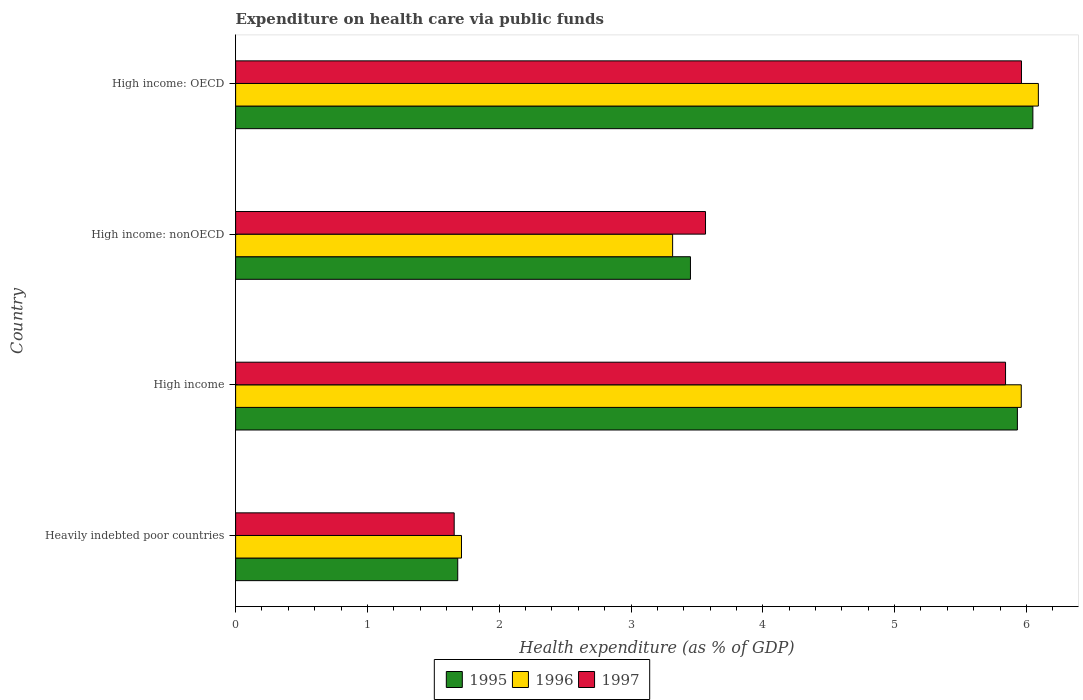Are the number of bars per tick equal to the number of legend labels?
Your answer should be compact. Yes. Are the number of bars on each tick of the Y-axis equal?
Your answer should be compact. Yes. How many bars are there on the 1st tick from the top?
Your answer should be very brief. 3. What is the label of the 2nd group of bars from the top?
Your response must be concise. High income: nonOECD. In how many cases, is the number of bars for a given country not equal to the number of legend labels?
Keep it short and to the point. 0. What is the expenditure made on health care in 1995 in High income?
Give a very brief answer. 5.93. Across all countries, what is the maximum expenditure made on health care in 1996?
Give a very brief answer. 6.09. Across all countries, what is the minimum expenditure made on health care in 1996?
Keep it short and to the point. 1.71. In which country was the expenditure made on health care in 1996 maximum?
Give a very brief answer. High income: OECD. In which country was the expenditure made on health care in 1996 minimum?
Your response must be concise. Heavily indebted poor countries. What is the total expenditure made on health care in 1995 in the graph?
Give a very brief answer. 17.12. What is the difference between the expenditure made on health care in 1997 in High income: OECD and that in High income: nonOECD?
Provide a short and direct response. 2.4. What is the difference between the expenditure made on health care in 1996 in Heavily indebted poor countries and the expenditure made on health care in 1995 in High income: nonOECD?
Your answer should be very brief. -1.74. What is the average expenditure made on health care in 1997 per country?
Provide a succinct answer. 4.26. What is the difference between the expenditure made on health care in 1995 and expenditure made on health care in 1997 in High income?
Offer a very short reply. 0.09. What is the ratio of the expenditure made on health care in 1997 in High income to that in High income: OECD?
Make the answer very short. 0.98. Is the expenditure made on health care in 1996 in High income less than that in High income: nonOECD?
Ensure brevity in your answer.  No. Is the difference between the expenditure made on health care in 1995 in High income: OECD and High income: nonOECD greater than the difference between the expenditure made on health care in 1997 in High income: OECD and High income: nonOECD?
Offer a terse response. Yes. What is the difference between the highest and the second highest expenditure made on health care in 1997?
Your response must be concise. 0.12. What is the difference between the highest and the lowest expenditure made on health care in 1995?
Provide a short and direct response. 4.36. In how many countries, is the expenditure made on health care in 1997 greater than the average expenditure made on health care in 1997 taken over all countries?
Provide a succinct answer. 2. Is the sum of the expenditure made on health care in 1997 in Heavily indebted poor countries and High income: nonOECD greater than the maximum expenditure made on health care in 1995 across all countries?
Your answer should be very brief. No. What does the 1st bar from the bottom in High income: nonOECD represents?
Offer a very short reply. 1995. Is it the case that in every country, the sum of the expenditure made on health care in 1997 and expenditure made on health care in 1995 is greater than the expenditure made on health care in 1996?
Your answer should be very brief. Yes. What is the difference between two consecutive major ticks on the X-axis?
Make the answer very short. 1. Does the graph contain grids?
Provide a succinct answer. No. Where does the legend appear in the graph?
Your response must be concise. Bottom center. What is the title of the graph?
Keep it short and to the point. Expenditure on health care via public funds. Does "1997" appear as one of the legend labels in the graph?
Keep it short and to the point. Yes. What is the label or title of the X-axis?
Make the answer very short. Health expenditure (as % of GDP). What is the label or title of the Y-axis?
Provide a succinct answer. Country. What is the Health expenditure (as % of GDP) in 1995 in Heavily indebted poor countries?
Keep it short and to the point. 1.69. What is the Health expenditure (as % of GDP) in 1996 in Heavily indebted poor countries?
Offer a terse response. 1.71. What is the Health expenditure (as % of GDP) in 1997 in Heavily indebted poor countries?
Provide a succinct answer. 1.66. What is the Health expenditure (as % of GDP) in 1995 in High income?
Your answer should be very brief. 5.93. What is the Health expenditure (as % of GDP) in 1996 in High income?
Keep it short and to the point. 5.96. What is the Health expenditure (as % of GDP) of 1997 in High income?
Offer a terse response. 5.84. What is the Health expenditure (as % of GDP) of 1995 in High income: nonOECD?
Offer a terse response. 3.45. What is the Health expenditure (as % of GDP) in 1996 in High income: nonOECD?
Make the answer very short. 3.32. What is the Health expenditure (as % of GDP) of 1997 in High income: nonOECD?
Your answer should be very brief. 3.57. What is the Health expenditure (as % of GDP) of 1995 in High income: OECD?
Offer a very short reply. 6.05. What is the Health expenditure (as % of GDP) of 1996 in High income: OECD?
Offer a very short reply. 6.09. What is the Health expenditure (as % of GDP) in 1997 in High income: OECD?
Your response must be concise. 5.96. Across all countries, what is the maximum Health expenditure (as % of GDP) of 1995?
Make the answer very short. 6.05. Across all countries, what is the maximum Health expenditure (as % of GDP) in 1996?
Make the answer very short. 6.09. Across all countries, what is the maximum Health expenditure (as % of GDP) in 1997?
Your response must be concise. 5.96. Across all countries, what is the minimum Health expenditure (as % of GDP) of 1995?
Your answer should be compact. 1.69. Across all countries, what is the minimum Health expenditure (as % of GDP) in 1996?
Provide a succinct answer. 1.71. Across all countries, what is the minimum Health expenditure (as % of GDP) of 1997?
Provide a succinct answer. 1.66. What is the total Health expenditure (as % of GDP) in 1995 in the graph?
Provide a short and direct response. 17.12. What is the total Health expenditure (as % of GDP) of 1996 in the graph?
Your answer should be compact. 17.08. What is the total Health expenditure (as % of GDP) of 1997 in the graph?
Ensure brevity in your answer.  17.03. What is the difference between the Health expenditure (as % of GDP) of 1995 in Heavily indebted poor countries and that in High income?
Provide a succinct answer. -4.25. What is the difference between the Health expenditure (as % of GDP) in 1996 in Heavily indebted poor countries and that in High income?
Provide a succinct answer. -4.25. What is the difference between the Health expenditure (as % of GDP) in 1997 in Heavily indebted poor countries and that in High income?
Provide a succinct answer. -4.18. What is the difference between the Health expenditure (as % of GDP) in 1995 in Heavily indebted poor countries and that in High income: nonOECD?
Offer a terse response. -1.77. What is the difference between the Health expenditure (as % of GDP) in 1996 in Heavily indebted poor countries and that in High income: nonOECD?
Your answer should be very brief. -1.6. What is the difference between the Health expenditure (as % of GDP) of 1997 in Heavily indebted poor countries and that in High income: nonOECD?
Give a very brief answer. -1.91. What is the difference between the Health expenditure (as % of GDP) in 1995 in Heavily indebted poor countries and that in High income: OECD?
Your answer should be compact. -4.36. What is the difference between the Health expenditure (as % of GDP) of 1996 in Heavily indebted poor countries and that in High income: OECD?
Your answer should be compact. -4.38. What is the difference between the Health expenditure (as % of GDP) of 1997 in Heavily indebted poor countries and that in High income: OECD?
Your answer should be compact. -4.3. What is the difference between the Health expenditure (as % of GDP) of 1995 in High income and that in High income: nonOECD?
Your answer should be compact. 2.48. What is the difference between the Health expenditure (as % of GDP) of 1996 in High income and that in High income: nonOECD?
Provide a short and direct response. 2.65. What is the difference between the Health expenditure (as % of GDP) of 1997 in High income and that in High income: nonOECD?
Keep it short and to the point. 2.28. What is the difference between the Health expenditure (as % of GDP) of 1995 in High income and that in High income: OECD?
Make the answer very short. -0.12. What is the difference between the Health expenditure (as % of GDP) of 1996 in High income and that in High income: OECD?
Provide a short and direct response. -0.13. What is the difference between the Health expenditure (as % of GDP) of 1997 in High income and that in High income: OECD?
Provide a short and direct response. -0.12. What is the difference between the Health expenditure (as % of GDP) in 1995 in High income: nonOECD and that in High income: OECD?
Offer a terse response. -2.6. What is the difference between the Health expenditure (as % of GDP) of 1996 in High income: nonOECD and that in High income: OECD?
Your answer should be compact. -2.77. What is the difference between the Health expenditure (as % of GDP) of 1997 in High income: nonOECD and that in High income: OECD?
Offer a terse response. -2.4. What is the difference between the Health expenditure (as % of GDP) of 1995 in Heavily indebted poor countries and the Health expenditure (as % of GDP) of 1996 in High income?
Give a very brief answer. -4.28. What is the difference between the Health expenditure (as % of GDP) of 1995 in Heavily indebted poor countries and the Health expenditure (as % of GDP) of 1997 in High income?
Make the answer very short. -4.16. What is the difference between the Health expenditure (as % of GDP) in 1996 in Heavily indebted poor countries and the Health expenditure (as % of GDP) in 1997 in High income?
Offer a terse response. -4.13. What is the difference between the Health expenditure (as % of GDP) in 1995 in Heavily indebted poor countries and the Health expenditure (as % of GDP) in 1996 in High income: nonOECD?
Your response must be concise. -1.63. What is the difference between the Health expenditure (as % of GDP) in 1995 in Heavily indebted poor countries and the Health expenditure (as % of GDP) in 1997 in High income: nonOECD?
Keep it short and to the point. -1.88. What is the difference between the Health expenditure (as % of GDP) in 1996 in Heavily indebted poor countries and the Health expenditure (as % of GDP) in 1997 in High income: nonOECD?
Ensure brevity in your answer.  -1.85. What is the difference between the Health expenditure (as % of GDP) in 1995 in Heavily indebted poor countries and the Health expenditure (as % of GDP) in 1996 in High income: OECD?
Offer a very short reply. -4.41. What is the difference between the Health expenditure (as % of GDP) of 1995 in Heavily indebted poor countries and the Health expenditure (as % of GDP) of 1997 in High income: OECD?
Offer a terse response. -4.28. What is the difference between the Health expenditure (as % of GDP) in 1996 in Heavily indebted poor countries and the Health expenditure (as % of GDP) in 1997 in High income: OECD?
Your answer should be very brief. -4.25. What is the difference between the Health expenditure (as % of GDP) in 1995 in High income and the Health expenditure (as % of GDP) in 1996 in High income: nonOECD?
Your answer should be very brief. 2.62. What is the difference between the Health expenditure (as % of GDP) of 1995 in High income and the Health expenditure (as % of GDP) of 1997 in High income: nonOECD?
Ensure brevity in your answer.  2.37. What is the difference between the Health expenditure (as % of GDP) in 1996 in High income and the Health expenditure (as % of GDP) in 1997 in High income: nonOECD?
Offer a terse response. 2.4. What is the difference between the Health expenditure (as % of GDP) of 1995 in High income and the Health expenditure (as % of GDP) of 1996 in High income: OECD?
Your answer should be compact. -0.16. What is the difference between the Health expenditure (as % of GDP) in 1995 in High income and the Health expenditure (as % of GDP) in 1997 in High income: OECD?
Offer a terse response. -0.03. What is the difference between the Health expenditure (as % of GDP) in 1996 in High income and the Health expenditure (as % of GDP) in 1997 in High income: OECD?
Give a very brief answer. -0. What is the difference between the Health expenditure (as % of GDP) in 1995 in High income: nonOECD and the Health expenditure (as % of GDP) in 1996 in High income: OECD?
Give a very brief answer. -2.64. What is the difference between the Health expenditure (as % of GDP) in 1995 in High income: nonOECD and the Health expenditure (as % of GDP) in 1997 in High income: OECD?
Your answer should be very brief. -2.51. What is the difference between the Health expenditure (as % of GDP) in 1996 in High income: nonOECD and the Health expenditure (as % of GDP) in 1997 in High income: OECD?
Offer a very short reply. -2.65. What is the average Health expenditure (as % of GDP) of 1995 per country?
Your response must be concise. 4.28. What is the average Health expenditure (as % of GDP) in 1996 per country?
Offer a very short reply. 4.27. What is the average Health expenditure (as % of GDP) of 1997 per country?
Your response must be concise. 4.26. What is the difference between the Health expenditure (as % of GDP) in 1995 and Health expenditure (as % of GDP) in 1996 in Heavily indebted poor countries?
Your answer should be compact. -0.03. What is the difference between the Health expenditure (as % of GDP) in 1995 and Health expenditure (as % of GDP) in 1997 in Heavily indebted poor countries?
Ensure brevity in your answer.  0.03. What is the difference between the Health expenditure (as % of GDP) of 1996 and Health expenditure (as % of GDP) of 1997 in Heavily indebted poor countries?
Your answer should be compact. 0.06. What is the difference between the Health expenditure (as % of GDP) in 1995 and Health expenditure (as % of GDP) in 1996 in High income?
Give a very brief answer. -0.03. What is the difference between the Health expenditure (as % of GDP) of 1995 and Health expenditure (as % of GDP) of 1997 in High income?
Offer a terse response. 0.09. What is the difference between the Health expenditure (as % of GDP) of 1996 and Health expenditure (as % of GDP) of 1997 in High income?
Offer a terse response. 0.12. What is the difference between the Health expenditure (as % of GDP) in 1995 and Health expenditure (as % of GDP) in 1996 in High income: nonOECD?
Provide a short and direct response. 0.14. What is the difference between the Health expenditure (as % of GDP) in 1995 and Health expenditure (as % of GDP) in 1997 in High income: nonOECD?
Ensure brevity in your answer.  -0.11. What is the difference between the Health expenditure (as % of GDP) of 1996 and Health expenditure (as % of GDP) of 1997 in High income: nonOECD?
Keep it short and to the point. -0.25. What is the difference between the Health expenditure (as % of GDP) of 1995 and Health expenditure (as % of GDP) of 1996 in High income: OECD?
Offer a terse response. -0.04. What is the difference between the Health expenditure (as % of GDP) in 1995 and Health expenditure (as % of GDP) in 1997 in High income: OECD?
Offer a very short reply. 0.09. What is the difference between the Health expenditure (as % of GDP) in 1996 and Health expenditure (as % of GDP) in 1997 in High income: OECD?
Your response must be concise. 0.13. What is the ratio of the Health expenditure (as % of GDP) of 1995 in Heavily indebted poor countries to that in High income?
Provide a short and direct response. 0.28. What is the ratio of the Health expenditure (as % of GDP) in 1996 in Heavily indebted poor countries to that in High income?
Provide a short and direct response. 0.29. What is the ratio of the Health expenditure (as % of GDP) of 1997 in Heavily indebted poor countries to that in High income?
Provide a succinct answer. 0.28. What is the ratio of the Health expenditure (as % of GDP) of 1995 in Heavily indebted poor countries to that in High income: nonOECD?
Offer a terse response. 0.49. What is the ratio of the Health expenditure (as % of GDP) in 1996 in Heavily indebted poor countries to that in High income: nonOECD?
Provide a short and direct response. 0.52. What is the ratio of the Health expenditure (as % of GDP) of 1997 in Heavily indebted poor countries to that in High income: nonOECD?
Provide a short and direct response. 0.47. What is the ratio of the Health expenditure (as % of GDP) of 1995 in Heavily indebted poor countries to that in High income: OECD?
Your response must be concise. 0.28. What is the ratio of the Health expenditure (as % of GDP) of 1996 in Heavily indebted poor countries to that in High income: OECD?
Offer a very short reply. 0.28. What is the ratio of the Health expenditure (as % of GDP) in 1997 in Heavily indebted poor countries to that in High income: OECD?
Provide a succinct answer. 0.28. What is the ratio of the Health expenditure (as % of GDP) of 1995 in High income to that in High income: nonOECD?
Your answer should be very brief. 1.72. What is the ratio of the Health expenditure (as % of GDP) of 1996 in High income to that in High income: nonOECD?
Offer a very short reply. 1.8. What is the ratio of the Health expenditure (as % of GDP) in 1997 in High income to that in High income: nonOECD?
Your answer should be very brief. 1.64. What is the ratio of the Health expenditure (as % of GDP) of 1995 in High income to that in High income: OECD?
Offer a very short reply. 0.98. What is the ratio of the Health expenditure (as % of GDP) in 1996 in High income to that in High income: OECD?
Ensure brevity in your answer.  0.98. What is the ratio of the Health expenditure (as % of GDP) in 1997 in High income to that in High income: OECD?
Your answer should be very brief. 0.98. What is the ratio of the Health expenditure (as % of GDP) of 1995 in High income: nonOECD to that in High income: OECD?
Offer a very short reply. 0.57. What is the ratio of the Health expenditure (as % of GDP) in 1996 in High income: nonOECD to that in High income: OECD?
Provide a short and direct response. 0.54. What is the ratio of the Health expenditure (as % of GDP) in 1997 in High income: nonOECD to that in High income: OECD?
Make the answer very short. 0.6. What is the difference between the highest and the second highest Health expenditure (as % of GDP) in 1995?
Provide a succinct answer. 0.12. What is the difference between the highest and the second highest Health expenditure (as % of GDP) in 1996?
Make the answer very short. 0.13. What is the difference between the highest and the second highest Health expenditure (as % of GDP) in 1997?
Your answer should be very brief. 0.12. What is the difference between the highest and the lowest Health expenditure (as % of GDP) of 1995?
Give a very brief answer. 4.36. What is the difference between the highest and the lowest Health expenditure (as % of GDP) of 1996?
Offer a very short reply. 4.38. What is the difference between the highest and the lowest Health expenditure (as % of GDP) of 1997?
Provide a short and direct response. 4.3. 